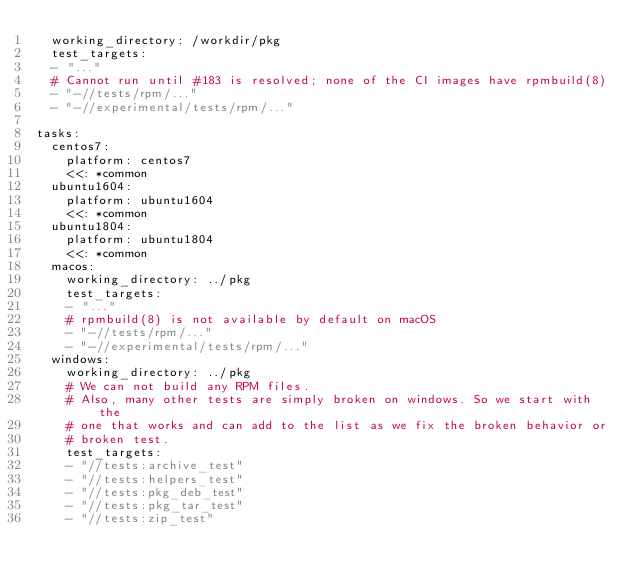<code> <loc_0><loc_0><loc_500><loc_500><_YAML_>  working_directory: /workdir/pkg
  test_targets:
  - "..."
  # Cannot run until #183 is resolved; none of the CI images have rpmbuild(8)
  - "-//tests/rpm/..."
  - "-//experimental/tests/rpm/..."

tasks:
  centos7:
    platform: centos7
    <<: *common
  ubuntu1604:
    platform: ubuntu1604
    <<: *common
  ubuntu1804:
    platform: ubuntu1804
    <<: *common
  macos:
    working_directory: ../pkg
    test_targets:
    - "..."
    # rpmbuild(8) is not available by default on macOS
    - "-//tests/rpm/..."
    - "-//experimental/tests/rpm/..."
  windows:
    working_directory: ../pkg
    # We can not build any RPM files.
    # Also, many other tests are simply broken on windows. So we start with the
    # one that works and can add to the list as we fix the broken behavior or
    # broken test.
    test_targets:
    - "//tests:archive_test"
    - "//tests:helpers_test"
    - "//tests:pkg_deb_test"
    - "//tests:pkg_tar_test"
    - "//tests:zip_test"

</code> 